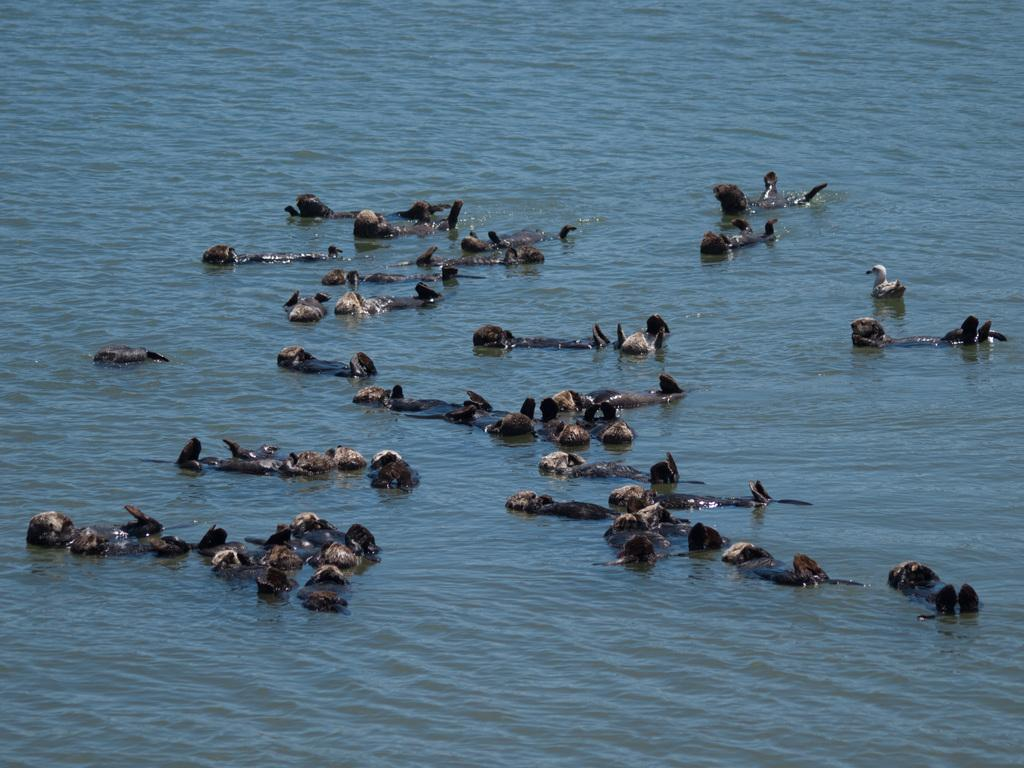What animals are present in the image? There is a group of ducks in the image. Where are the ducks located? The ducks are on water. What type of insurance do the ducks have in the image? There is no information about insurance for the ducks in the image, as it focuses on their presence and location. 